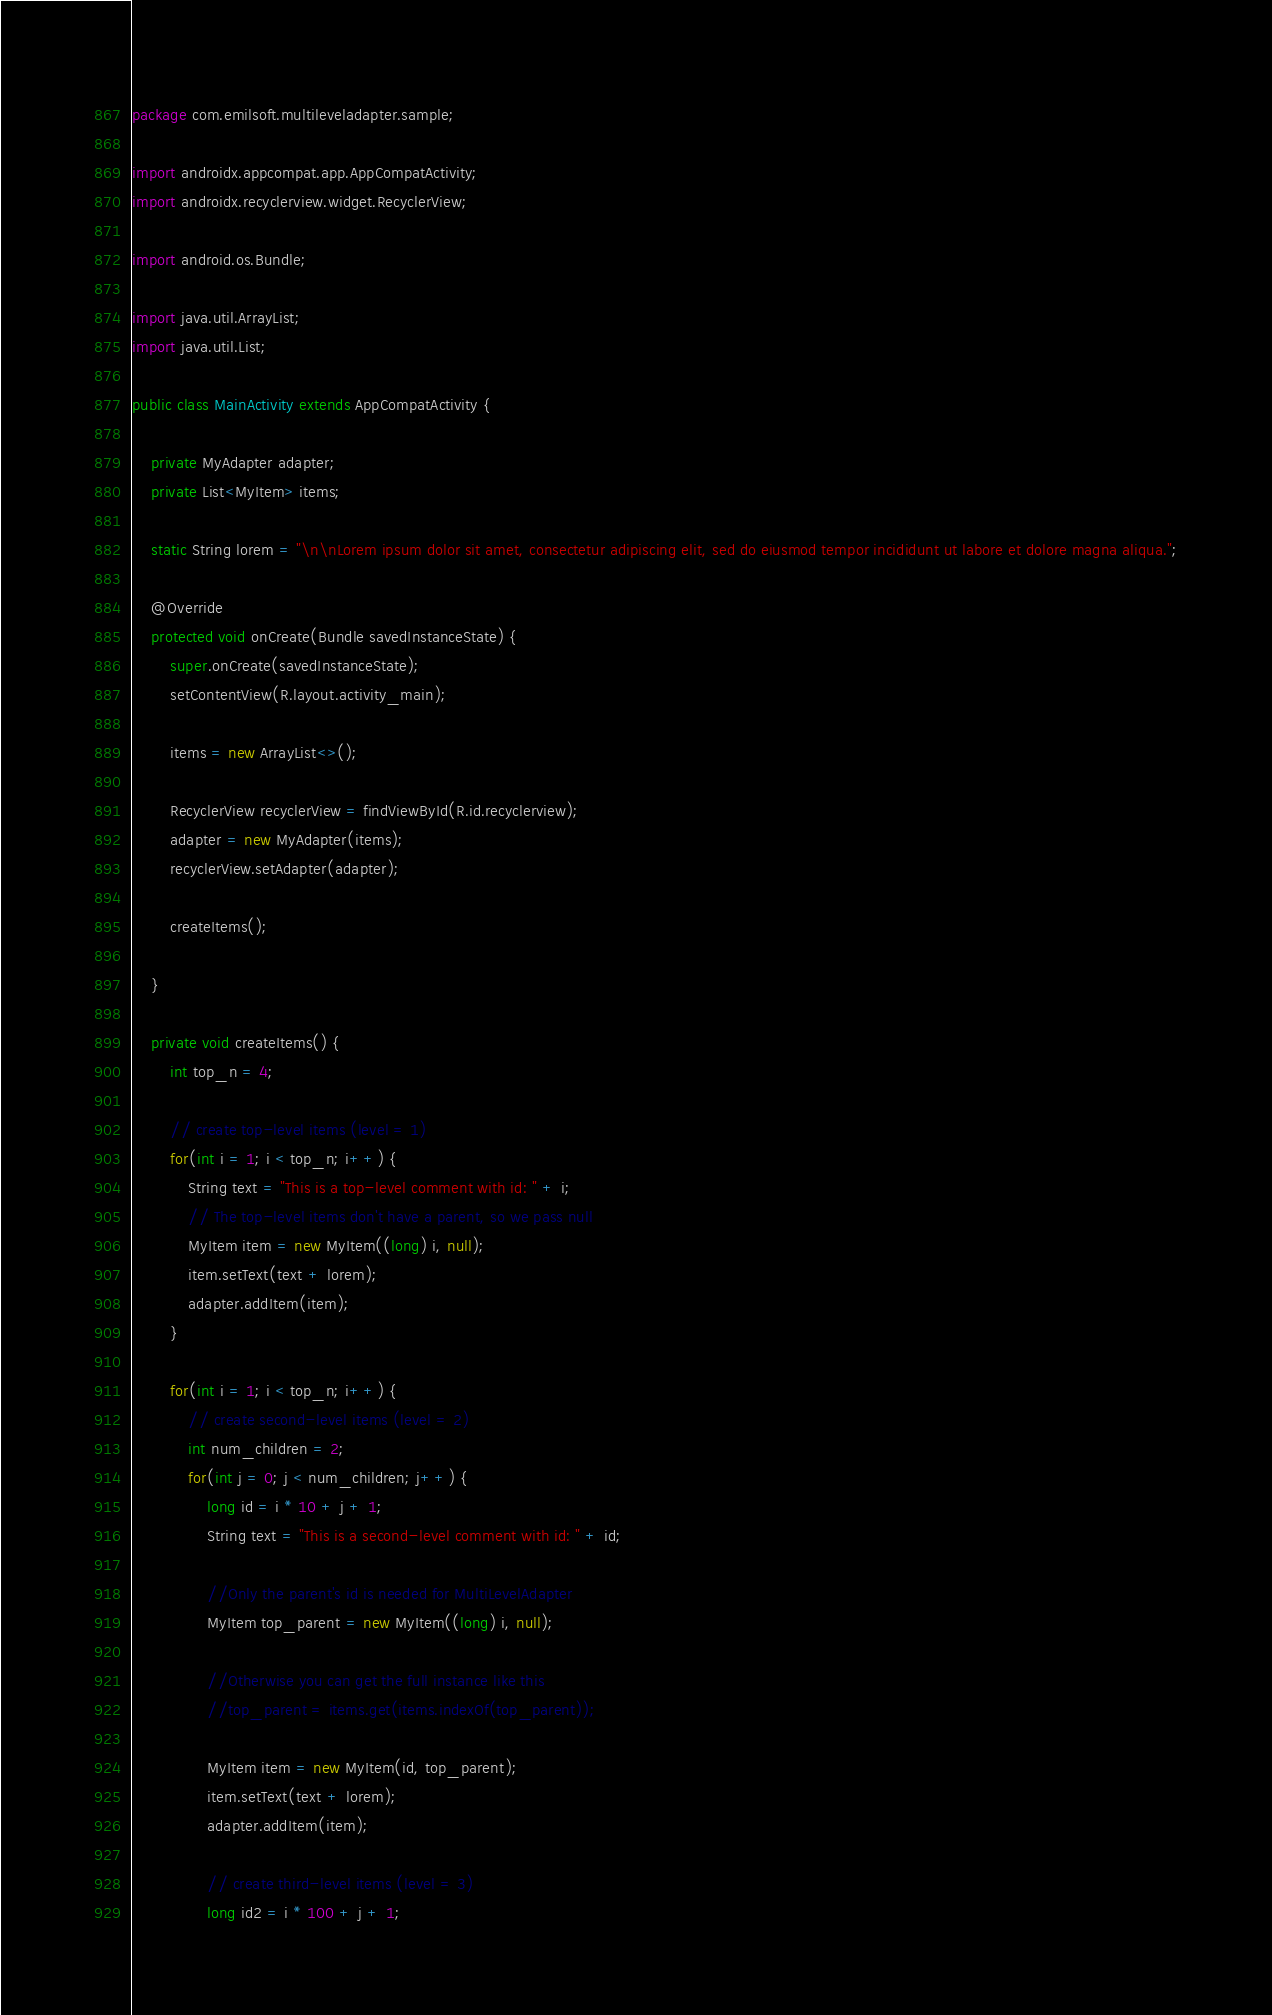Convert code to text. <code><loc_0><loc_0><loc_500><loc_500><_Java_>package com.emilsoft.multileveladapter.sample;

import androidx.appcompat.app.AppCompatActivity;
import androidx.recyclerview.widget.RecyclerView;

import android.os.Bundle;

import java.util.ArrayList;
import java.util.List;

public class MainActivity extends AppCompatActivity {

    private MyAdapter adapter;
    private List<MyItem> items;

    static String lorem = "\n\nLorem ipsum dolor sit amet, consectetur adipiscing elit, sed do eiusmod tempor incididunt ut labore et dolore magna aliqua.";

    @Override
    protected void onCreate(Bundle savedInstanceState) {
        super.onCreate(savedInstanceState);
        setContentView(R.layout.activity_main);

        items = new ArrayList<>();

        RecyclerView recyclerView = findViewById(R.id.recyclerview);
        adapter = new MyAdapter(items);
        recyclerView.setAdapter(adapter);

        createItems();

    }

    private void createItems() {
        int top_n = 4;

        // create top-level items (level = 1)
        for(int i = 1; i < top_n; i++) {
            String text = "This is a top-level comment with id: " + i;
            // The top-level items don't have a parent, so we pass null
            MyItem item = new MyItem((long) i, null);
            item.setText(text + lorem);
            adapter.addItem(item);
        }

        for(int i = 1; i < top_n; i++) {
            // create second-level items (level = 2)
            int num_children = 2;
            for(int j = 0; j < num_children; j++) {
                long id = i * 10 + j + 1;
                String text = "This is a second-level comment with id: " + id;

                //Only the parent's id is needed for MultiLevelAdapter
                MyItem top_parent = new MyItem((long) i, null);

                //Otherwise you can get the full instance like this
                //top_parent = items.get(items.indexOf(top_parent));

                MyItem item = new MyItem(id, top_parent);
                item.setText(text + lorem);
                adapter.addItem(item);

                // create third-level items (level = 3)
                long id2 = i * 100 + j + 1;</code> 